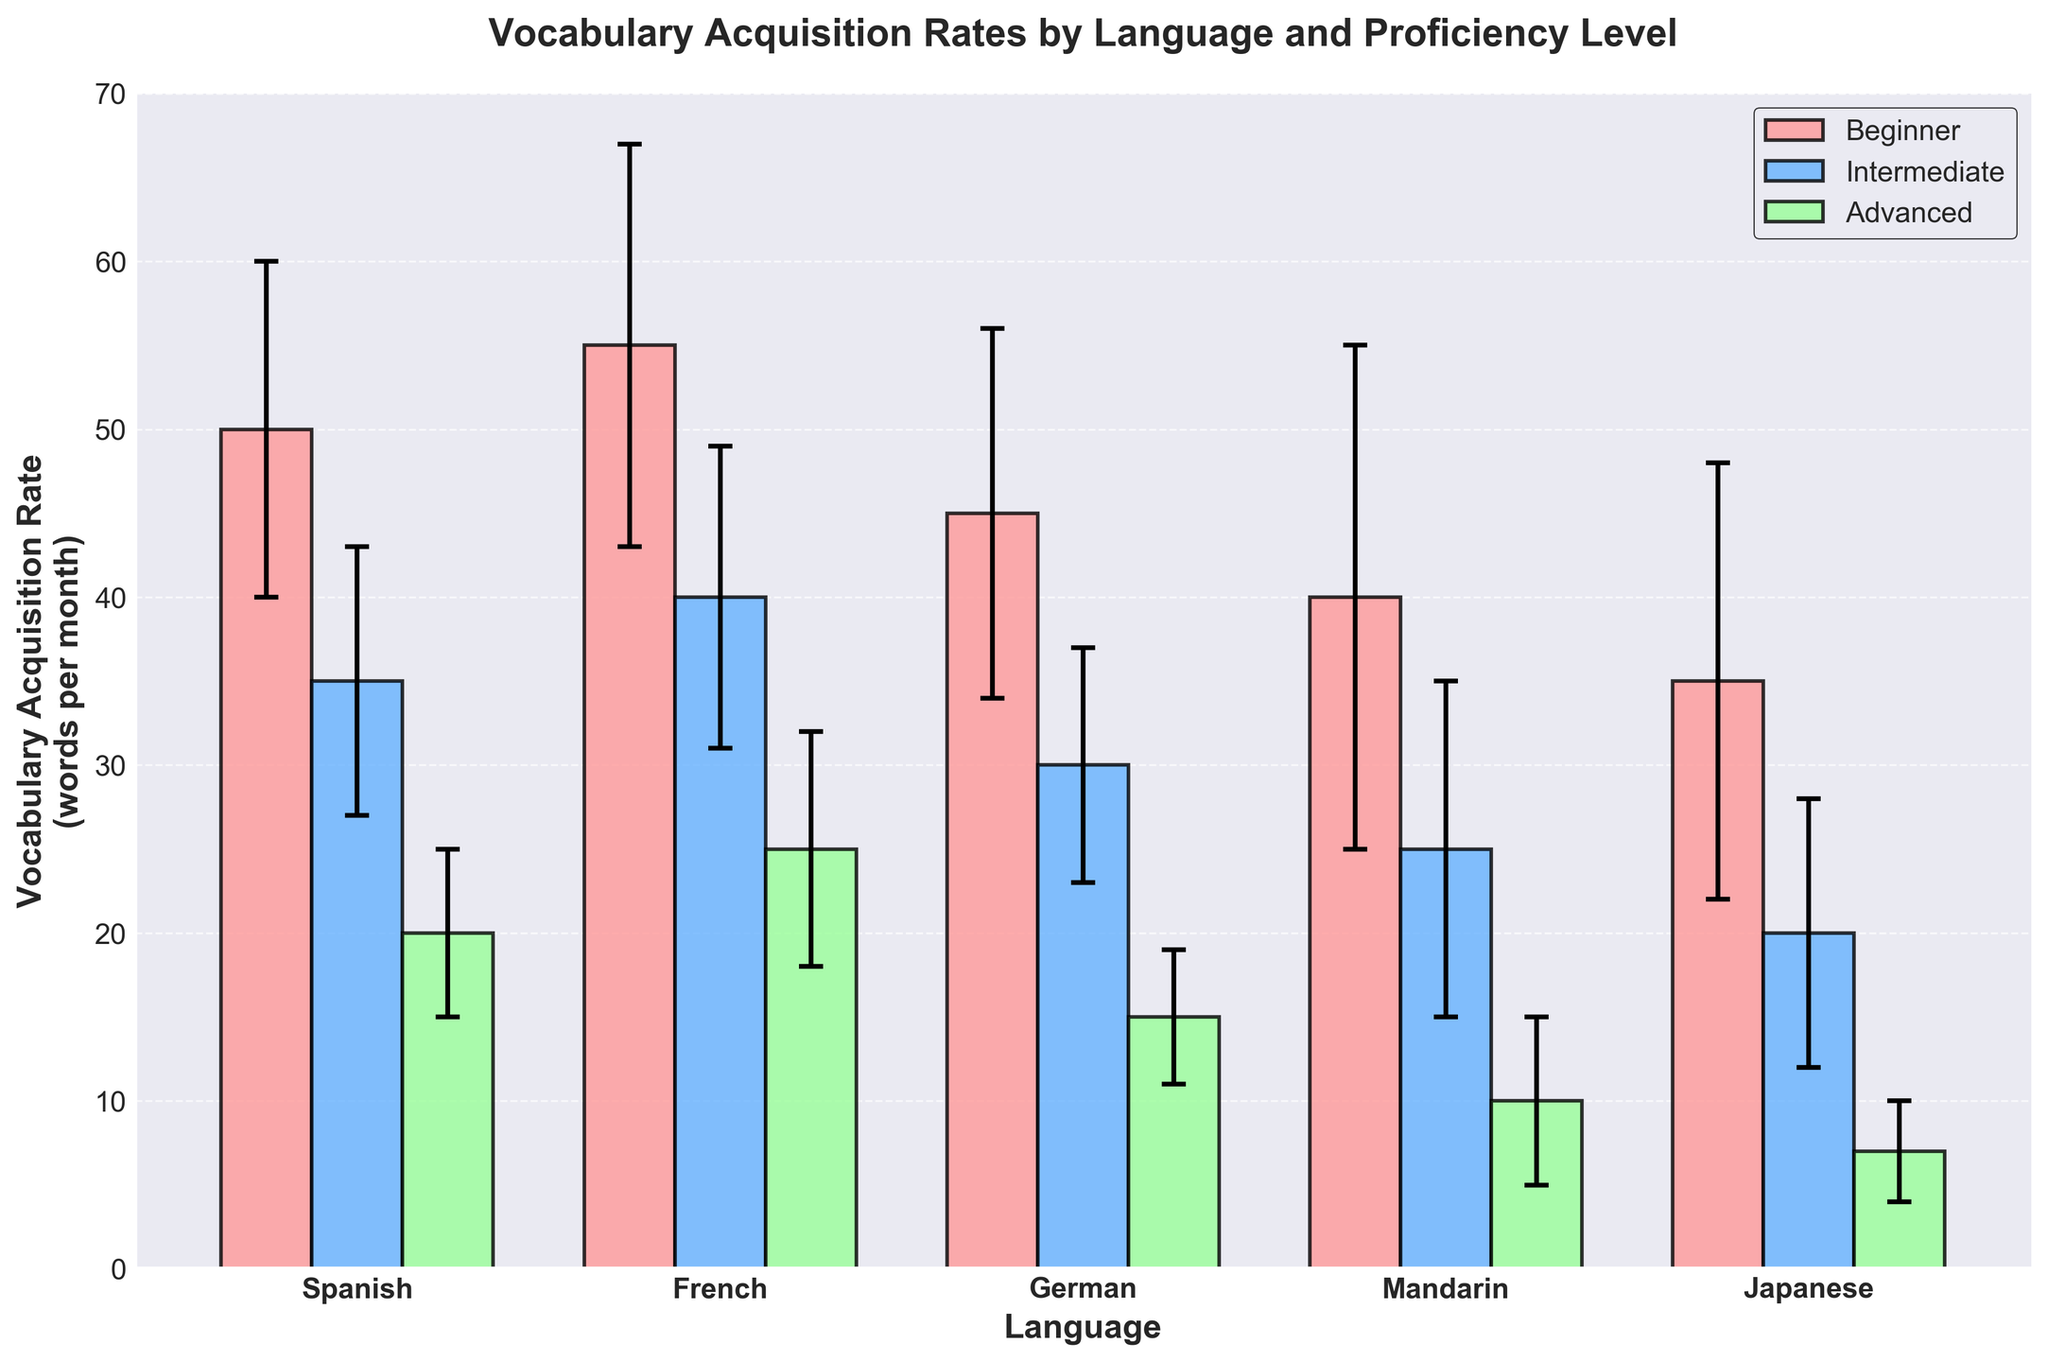How many languages are represented in the chart? Count the number of unique languages present on the x-axis. There are five unique languages.
Answer: 5 Which language has the highest mean vocabulary acquisition rate for beginner learners? Identify the tallest bar in the "Beginner" group. For Spanish, the mean is 50, for French it is 55, for German it is 45, for Mandarin it is 40, and for Japanese it is 35. French is the highest.
Answer: French What is the difference in the mean vocabulary acquisition rate between intermediate and advanced learners for German? Subtract the mean for advanced (15) from the mean for intermediate (30). The difference is 30 - 15.
Answer: 15 Which proficiency level has the highest variability (standard deviation) in vocabulary acquisition rates across all languages? Compare the error bars for all proficiency levels. Beginners have the highest standard deviations consistently: Spanish (10), French (12), German (11), Mandarin (15), Japanese (13). Mandarin beginners have the single highest value at 15.
Answer: Beginner How does the mean vocabulary acquisition rate for intermediate learners of Mandarin compare to advanced learners of French? Compare the height of the bars for intermediate Mandarin (25) and advanced French (25). They are equal.
Answer: They are equal Which language has the lowest mean vocabulary acquisition rate at the advanced level? Identify the shortest bar in the "Advanced" group. For Spanish, it is 20, for French it is 25, for German it is 15, for Mandarin it is 10, and for Japanese it is 7. Japanese is the lowest.
Answer: Japanese What is the mean vocabulary acquisition rate for all proficiency levels combined for Spanish? Add the means for all proficiency levels in Spanish and divide by the number of levels. (50 + 35 + 20) / 3 = 105 / 3 = 35
Answer: 35 Is the standard deviation for intermediate Spanish learners smaller than that for advanced French learners? Compare the error bars for intermediate Spanish (8) and advanced French (7). 8 is larger than 7.
Answer: No Which group has a higher mean vocabulary acquisition rate: beginner Japanese learners or advanced Spanish learners? Compare the height of the bars for beginner Japanese (35) and advanced Spanish (20). 35 is greater than 20.
Answer: Beginner Japanese learners What is the combined mean vocabulary acquisition rate for intermediate and advanced French learners? Add the means for intermediate French (40) and advanced French (25). 40 + 25 = 65
Answer: 65 